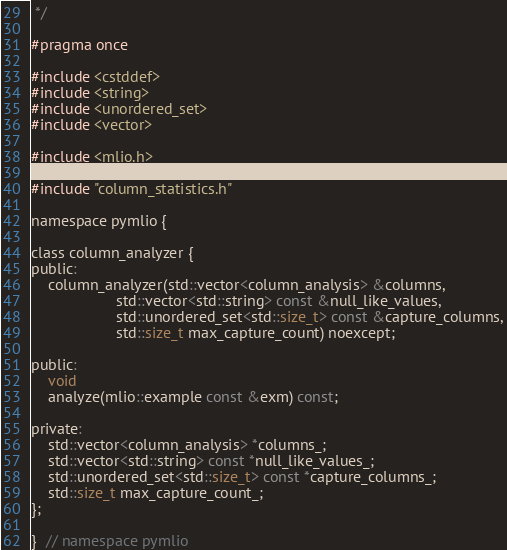Convert code to text. <code><loc_0><loc_0><loc_500><loc_500><_C_> */

#pragma once

#include <cstddef>
#include <string>
#include <unordered_set>
#include <vector>

#include <mlio.h>

#include "column_statistics.h"

namespace pymlio {

class column_analyzer {
public:
    column_analyzer(std::vector<column_analysis> &columns,
                    std::vector<std::string> const &null_like_values,
                    std::unordered_set<std::size_t> const &capture_columns,
                    std::size_t max_capture_count) noexcept;

public:
    void
    analyze(mlio::example const &exm) const;

private:
    std::vector<column_analysis> *columns_;
    std::vector<std::string> const *null_like_values_;
    std::unordered_set<std::size_t> const *capture_columns_;
    std::size_t max_capture_count_;
};

}  // namespace pymlio
</code> 